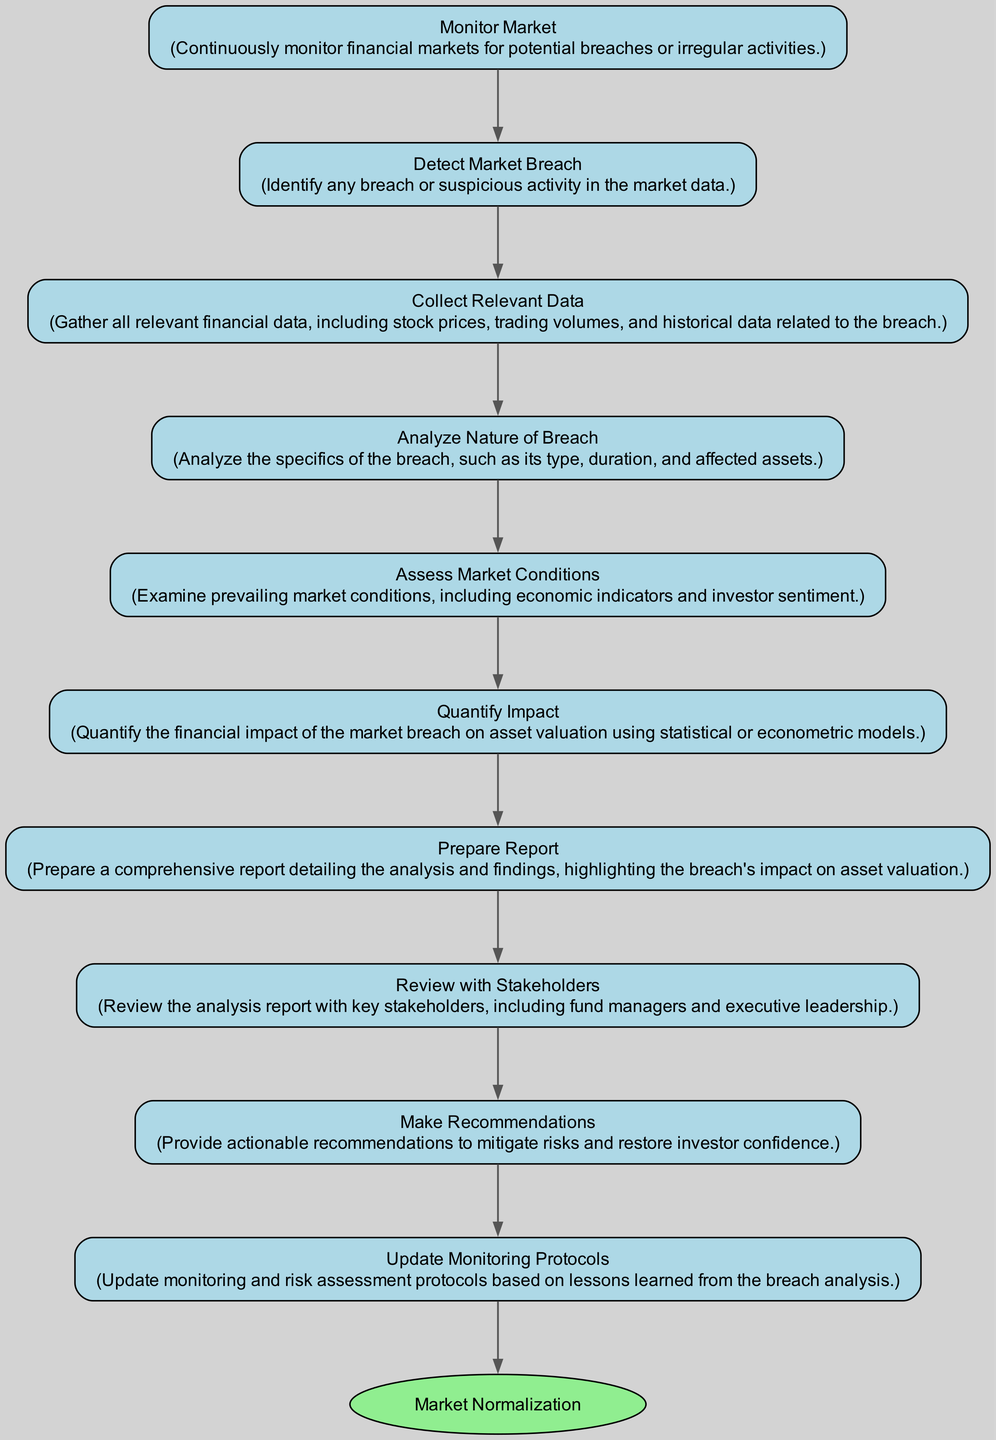What is the first action in the diagram? The first action in the diagram is "Monitor Market," which is the initial step in the process of assessing and quantifying market breach impact.
Answer: Monitor Market How many actions are there in total? The diagram contains a total of 10 actions, including the final end action.
Answer: 10 What comes immediately after detecting a market breach? After "Detect Market Breach," the next step is "Collect Relevant Data," indicating the collection of data following the detection of a breach.
Answer: Collect Relevant Data Which action focuses on investor sentiment? The action that focuses on investor sentiment is "Assess Market Conditions," as this step examines prevailing market factors that influence investor behavior.
Answer: Assess Market Conditions What is the last action before market normalization? The last action before "Market Normalization" is "Update Monitoring Protocols," indicating a step to refine future monitoring practices.
Answer: Update Monitoring Protocols What action involves stakeholders? The action that involves stakeholders is "Review with Stakeholders," which highlights the engagement with key individuals to present the findings.
Answer: Review with Stakeholders Which action aims to restore investor confidence? The action that aims to restore investor confidence is "Make Recommendations," as this step provides suggestions to strengthen market trust post-breach.
Answer: Make Recommendations What is the type of the last node in the diagram? The last node, "Market Normalization," is of type "end," indicating the conclusion of the activity sequence after all actions are completed.
Answer: end What does "Quantify Impact" analyze? "Quantify Impact" analyzes the financial impact of the market breach on asset valuation using statistical or econometric models for quantification.
Answer: financial impact What action immediately follows "Analyze Nature of Breach"? The action that immediately follows "Analyze Nature of Breach" is "Assess Market Conditions," signaling a transition from analysis to assessing the broader market factors.
Answer: Assess Market Conditions 